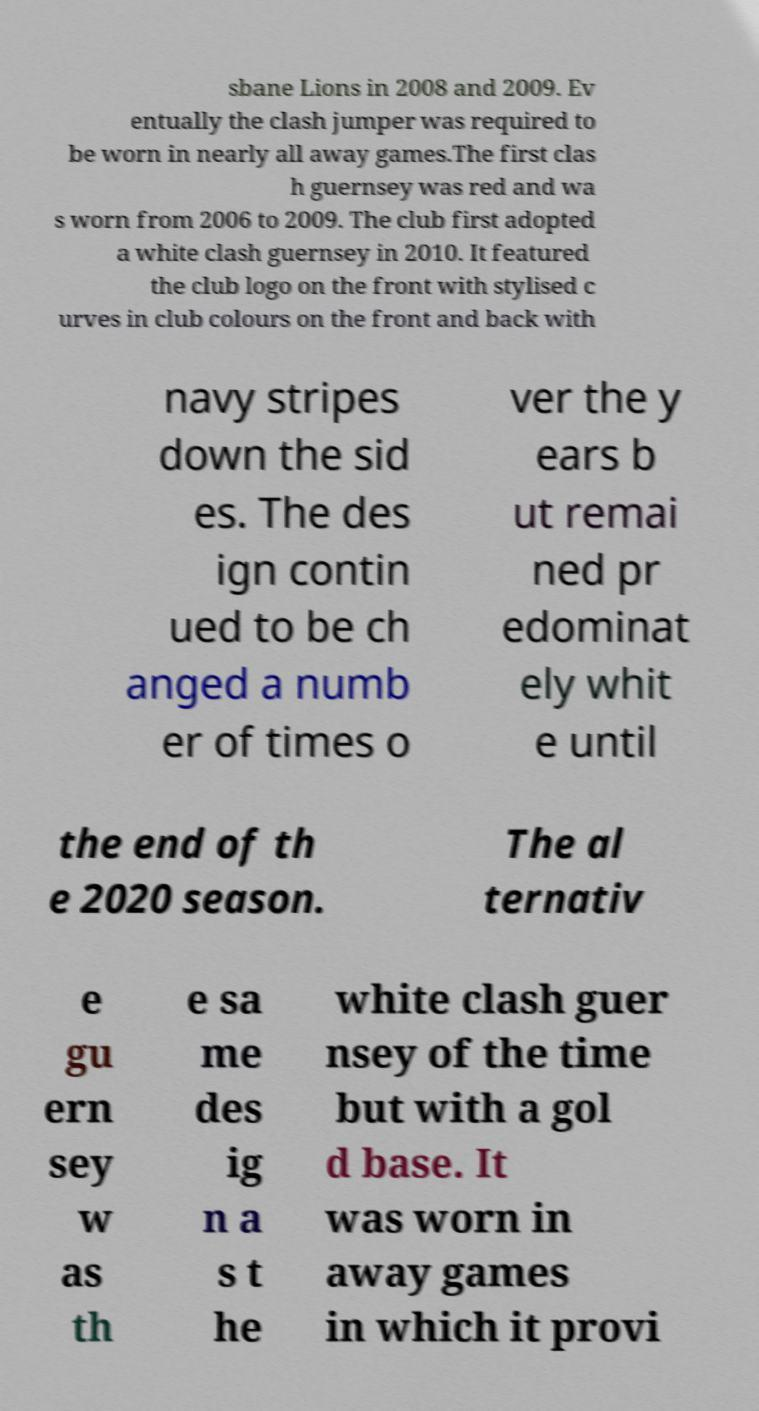There's text embedded in this image that I need extracted. Can you transcribe it verbatim? sbane Lions in 2008 and 2009. Ev entually the clash jumper was required to be worn in nearly all away games.The first clas h guernsey was red and wa s worn from 2006 to 2009. The club first adopted a white clash guernsey in 2010. It featured the club logo on the front with stylised c urves in club colours on the front and back with navy stripes down the sid es. The des ign contin ued to be ch anged a numb er of times o ver the y ears b ut remai ned pr edominat ely whit e until the end of th e 2020 season. The al ternativ e gu ern sey w as th e sa me des ig n a s t he white clash guer nsey of the time but with a gol d base. It was worn in away games in which it provi 